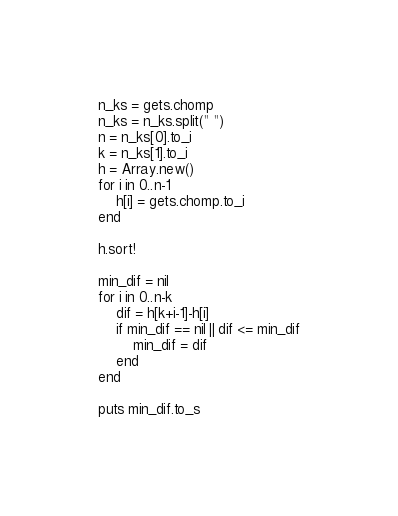<code> <loc_0><loc_0><loc_500><loc_500><_Ruby_>n_ks = gets.chomp
n_ks = n_ks.split(" ")
n = n_ks[0].to_i
k = n_ks[1].to_i
h = Array.new()
for i in 0..n-1
	h[i] = gets.chomp.to_i
end

h.sort!

min_dif = nil
for i in 0..n-k
	dif = h[k+i-1]-h[i]
	if min_dif == nil || dif <= min_dif
		min_dif = dif
	end
end

puts min_dif.to_s</code> 